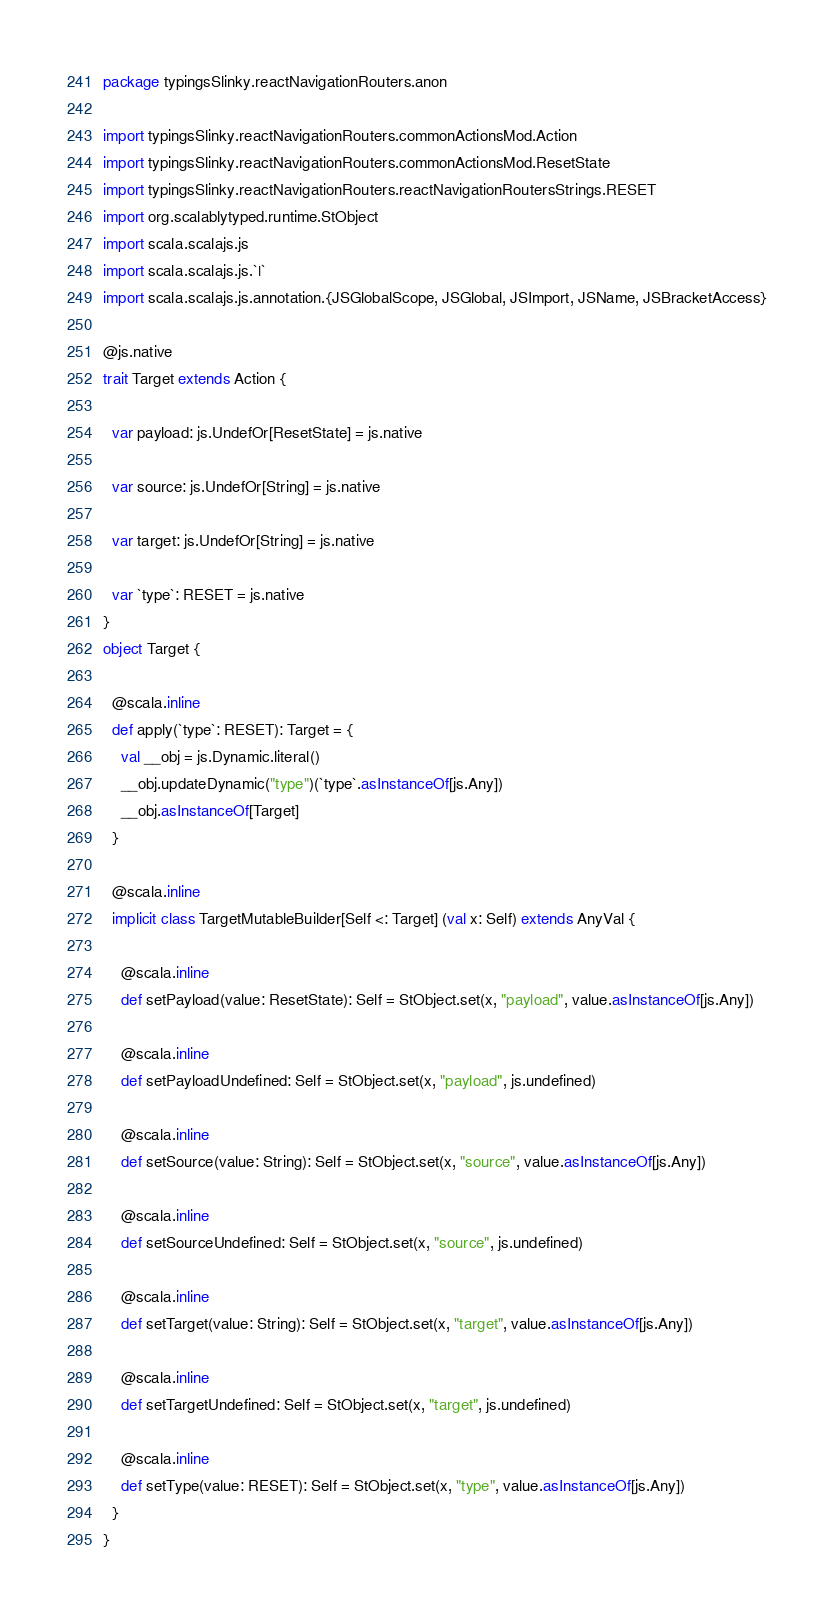Convert code to text. <code><loc_0><loc_0><loc_500><loc_500><_Scala_>package typingsSlinky.reactNavigationRouters.anon

import typingsSlinky.reactNavigationRouters.commonActionsMod.Action
import typingsSlinky.reactNavigationRouters.commonActionsMod.ResetState
import typingsSlinky.reactNavigationRouters.reactNavigationRoutersStrings.RESET
import org.scalablytyped.runtime.StObject
import scala.scalajs.js
import scala.scalajs.js.`|`
import scala.scalajs.js.annotation.{JSGlobalScope, JSGlobal, JSImport, JSName, JSBracketAccess}

@js.native
trait Target extends Action {
  
  var payload: js.UndefOr[ResetState] = js.native
  
  var source: js.UndefOr[String] = js.native
  
  var target: js.UndefOr[String] = js.native
  
  var `type`: RESET = js.native
}
object Target {
  
  @scala.inline
  def apply(`type`: RESET): Target = {
    val __obj = js.Dynamic.literal()
    __obj.updateDynamic("type")(`type`.asInstanceOf[js.Any])
    __obj.asInstanceOf[Target]
  }
  
  @scala.inline
  implicit class TargetMutableBuilder[Self <: Target] (val x: Self) extends AnyVal {
    
    @scala.inline
    def setPayload(value: ResetState): Self = StObject.set(x, "payload", value.asInstanceOf[js.Any])
    
    @scala.inline
    def setPayloadUndefined: Self = StObject.set(x, "payload", js.undefined)
    
    @scala.inline
    def setSource(value: String): Self = StObject.set(x, "source", value.asInstanceOf[js.Any])
    
    @scala.inline
    def setSourceUndefined: Self = StObject.set(x, "source", js.undefined)
    
    @scala.inline
    def setTarget(value: String): Self = StObject.set(x, "target", value.asInstanceOf[js.Any])
    
    @scala.inline
    def setTargetUndefined: Self = StObject.set(x, "target", js.undefined)
    
    @scala.inline
    def setType(value: RESET): Self = StObject.set(x, "type", value.asInstanceOf[js.Any])
  }
}
</code> 